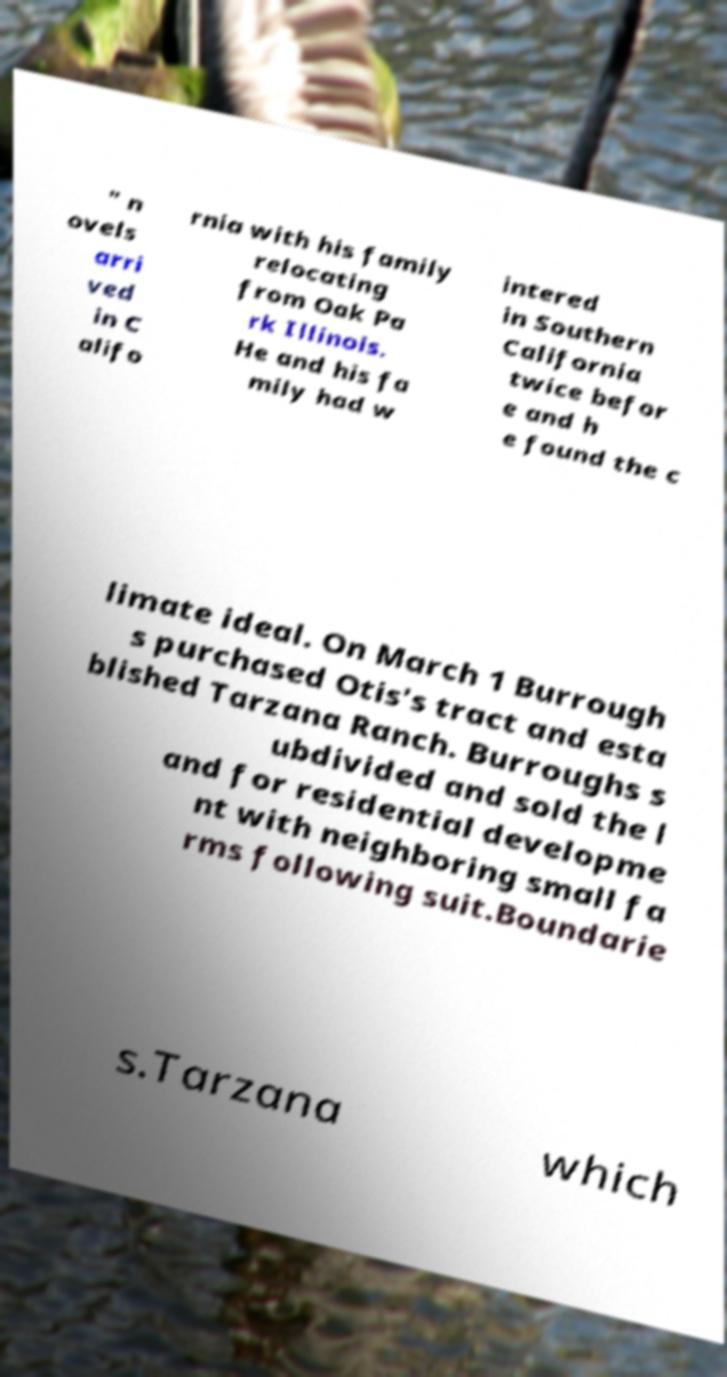There's text embedded in this image that I need extracted. Can you transcribe it verbatim? " n ovels arri ved in C alifo rnia with his family relocating from Oak Pa rk Illinois. He and his fa mily had w intered in Southern California twice befor e and h e found the c limate ideal. On March 1 Burrough s purchased Otis's tract and esta blished Tarzana Ranch. Burroughs s ubdivided and sold the l and for residential developme nt with neighboring small fa rms following suit.Boundarie s.Tarzana which 